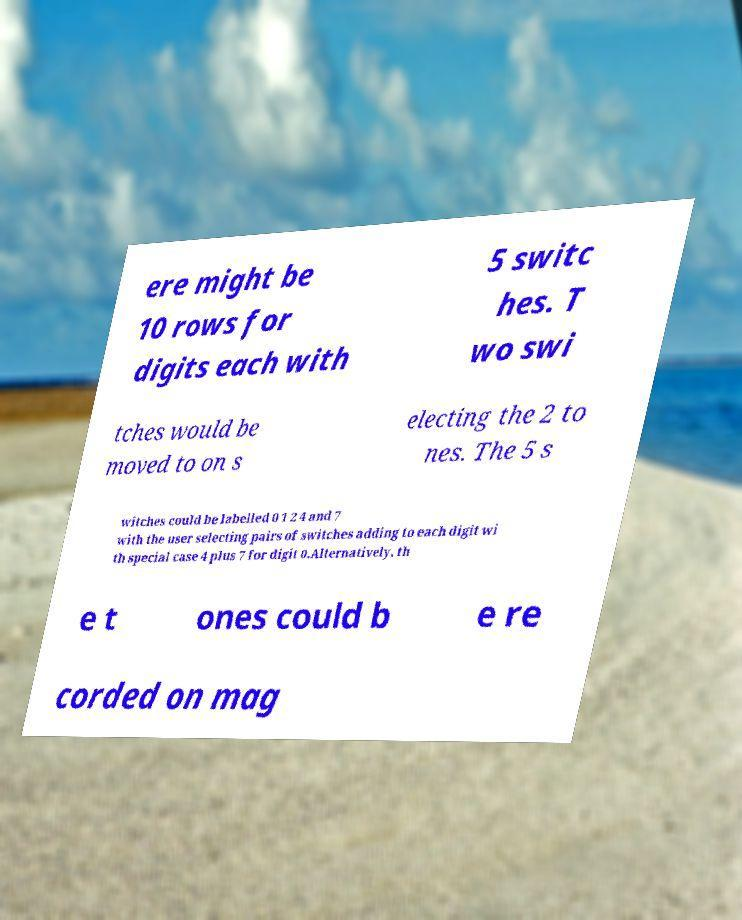What messages or text are displayed in this image? I need them in a readable, typed format. ere might be 10 rows for digits each with 5 switc hes. T wo swi tches would be moved to on s electing the 2 to nes. The 5 s witches could be labelled 0 1 2 4 and 7 with the user selecting pairs of switches adding to each digit wi th special case 4 plus 7 for digit 0.Alternatively, th e t ones could b e re corded on mag 